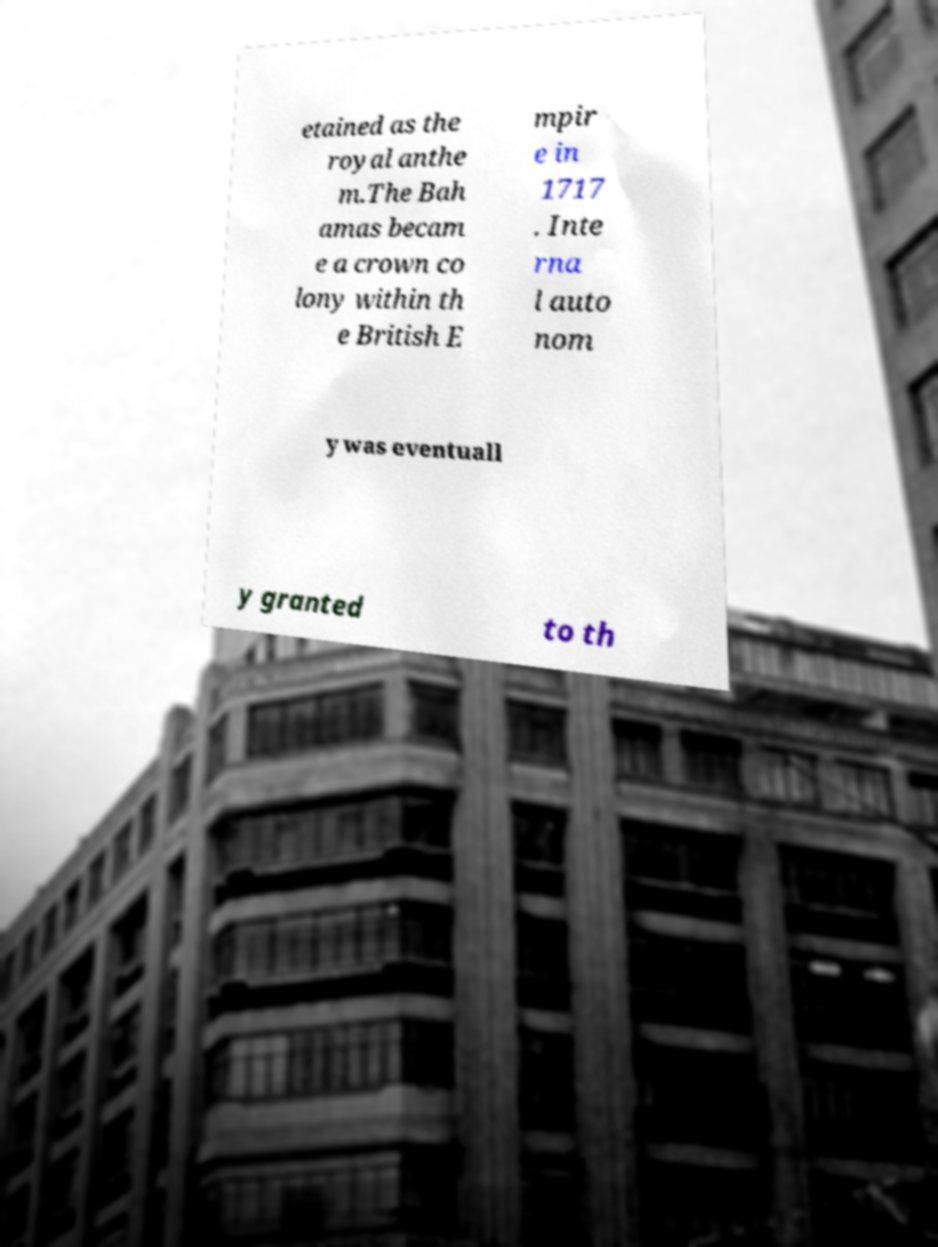Could you extract and type out the text from this image? etained as the royal anthe m.The Bah amas becam e a crown co lony within th e British E mpir e in 1717 . Inte rna l auto nom y was eventuall y granted to th 